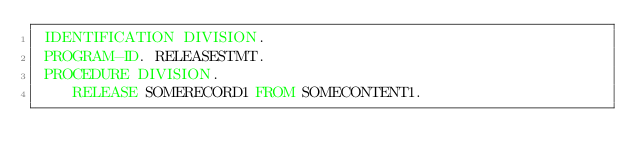Convert code to text. <code><loc_0><loc_0><loc_500><loc_500><_COBOL_> IDENTIFICATION DIVISION.
 PROGRAM-ID. RELEASESTMT.
 PROCEDURE DIVISION.
    RELEASE SOMERECORD1 FROM SOMECONTENT1.</code> 